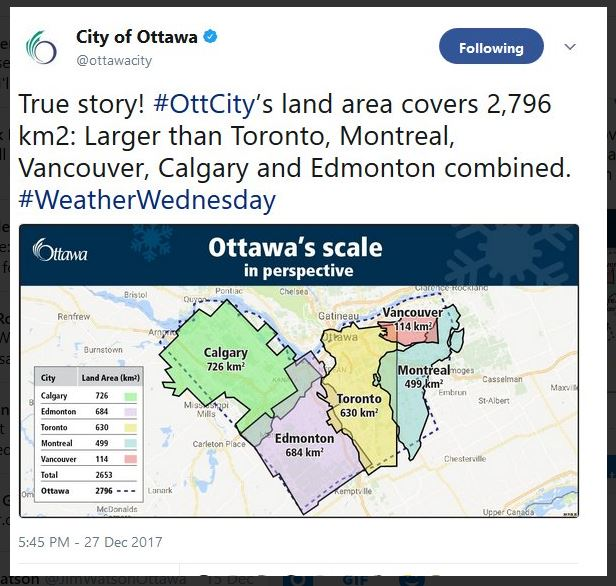Imagine Ottawa's land area as a fantastical realm. What unique features might exist in such a large, magical city? In a fantastical realm where Ottawa's large land area is a magical city, the landscape would be dotted with enchanted forests where trees glow with bioluminescence at night, providing natural light for nocturnal visitors. There would be vast meadows of flowers that change colors with the seasons, and rivers that sing soothing melodies. Majestic castles, each representing different elements like fire, water, earth, and air, would be spread across the landscape, governing their respective domains. The transport system could include mystical creatures like flying griffins or floating carriages, providing quick and scenic travel across the city. Protected by ancient spells, this realm would have areas where time flows differently, allowing for unique experiences and adventures. 